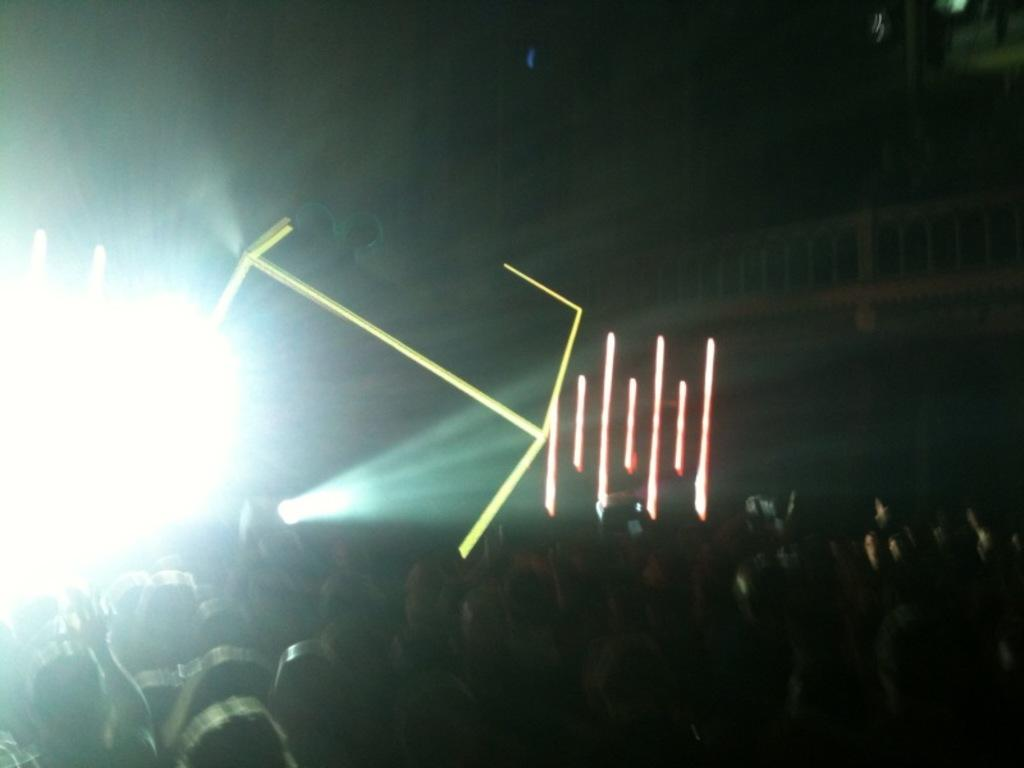Who or what can be seen in the image? There are people in the image. What else is present in the image besides the people? There are lights in the image. Can you describe the background of the image? The background of the image is dark. What type of hospital equipment can be seen in the image? There is no hospital equipment present in the image; it features people and lights with a dark background. Can you tell me how many kittens are visible in the image? There are no kittens present in the image. 